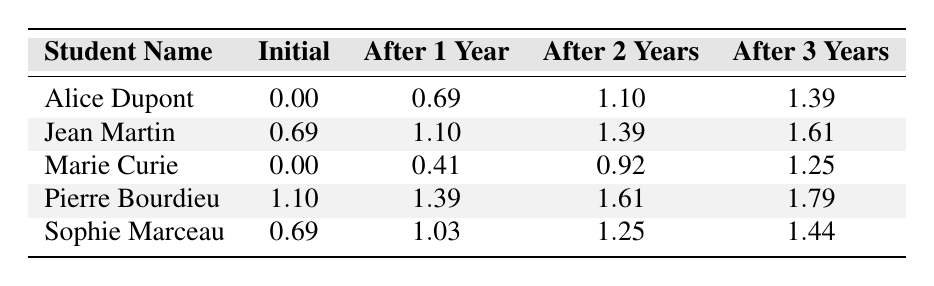What is the initial proficiency level of Alice Dupont? From the table, the initial proficiency level of Alice Dupont is found in the "Initial" column corresponding to her name, which shows a value of 0.00.
Answer: 0.00 Which student has the highest proficiency level after 2 years? To determine this, we should check the "After 2 Years" column for all students. The highest value in this column is 1.79, which corresponds to Pierre Bourdieu.
Answer: Pierre Bourdieu What is the average proficiency level after 3 years among all students? To find the average, we first sum the values in the "After 3 Years" column: (1.39 + 1.61 + 1.25 + 1.79 + 1.44) = 7.48. There are 5 students, so the average is 7.48 / 5 = 1.496.
Answer: 1.496 Did Marie Curie achieve a proficiency level greater than 1.00 after 1 year? Checking the "After 1 Year" column for Marie Curie, the value is 0.41 which is less than 1.00, so the answer is no.
Answer: No Which student had the smallest increase in proficiency level after 1 year? We need to calculate the increase for each student from their initial level to the "After 1 Year" level. For Marie Curie, the increase is 0.41 - 0.00 = 0.41; for Alice Dupont, it's 0.69 - 0.00 = 0.69; for Jean Martin, it's 1.10 - 0.69 = 0.41; for Pierre Bourdieu, it's 1.39 - 1.10 = 0.29; and for Sophie Marceau, it's 1.03 - 0.69 = 0.34. The smallest increase is therefore 0.29 for Pierre Bourdieu.
Answer: Pierre Bourdieu Is Sophie Marceau’s proficiency level after 3 years higher than Jean Martin's? Checking the respective values in the "After 3 Years" column, Sophie Marceau has a value of 1.44 and Jean Martin has 1.61. Since 1.44 is less than 1.61, the answer is no.
Answer: No 